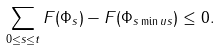<formula> <loc_0><loc_0><loc_500><loc_500>\sum _ { 0 \leq s \leq t } F ( \Phi _ { s } ) - F ( \Phi _ { s \min u s } ) \leq 0 .</formula> 